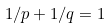Convert formula to latex. <formula><loc_0><loc_0><loc_500><loc_500>1 / p + 1 / q = 1</formula> 